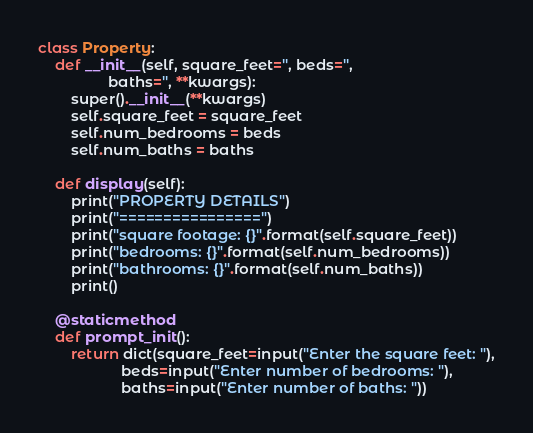Convert code to text. <code><loc_0><loc_0><loc_500><loc_500><_Python_>class Property:
    def __init__(self, square_feet='', beds='',
                 baths='', **kwargs):
        super().__init__(**kwargs)
        self.square_feet = square_feet
        self.num_bedrooms = beds
        self.num_baths = baths

    def display(self):
        print("PROPERTY DETAILS")
        print("================")
        print("square footage: {}".format(self.square_feet))
        print("bedrooms: {}".format(self.num_bedrooms))
        print("bathrooms: {}".format(self.num_baths))
        print()

    @staticmethod
    def prompt_init():
        return dict(square_feet=input("Enter the square feet: "),
                    beds=input("Enter number of bedrooms: "),
                    baths=input("Enter number of baths: "))

</code> 